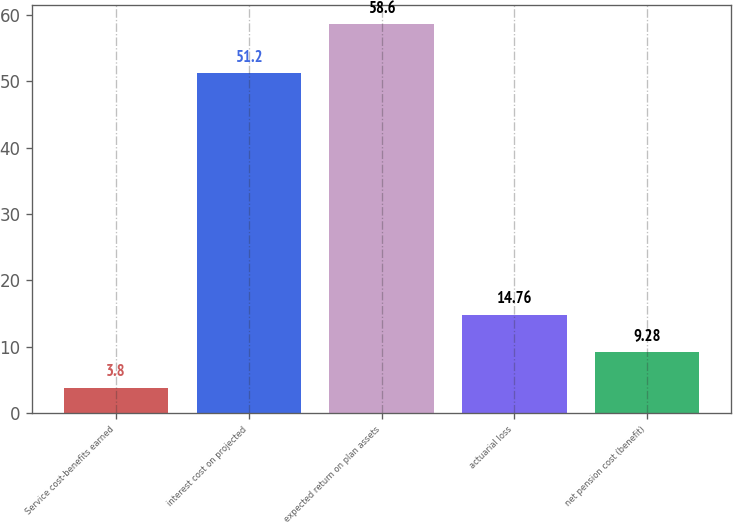Convert chart. <chart><loc_0><loc_0><loc_500><loc_500><bar_chart><fcel>Service cost-benefits earned<fcel>interest cost on projected<fcel>expected return on plan assets<fcel>actuarial loss<fcel>net pension cost (benefit)<nl><fcel>3.8<fcel>51.2<fcel>58.6<fcel>14.76<fcel>9.28<nl></chart> 